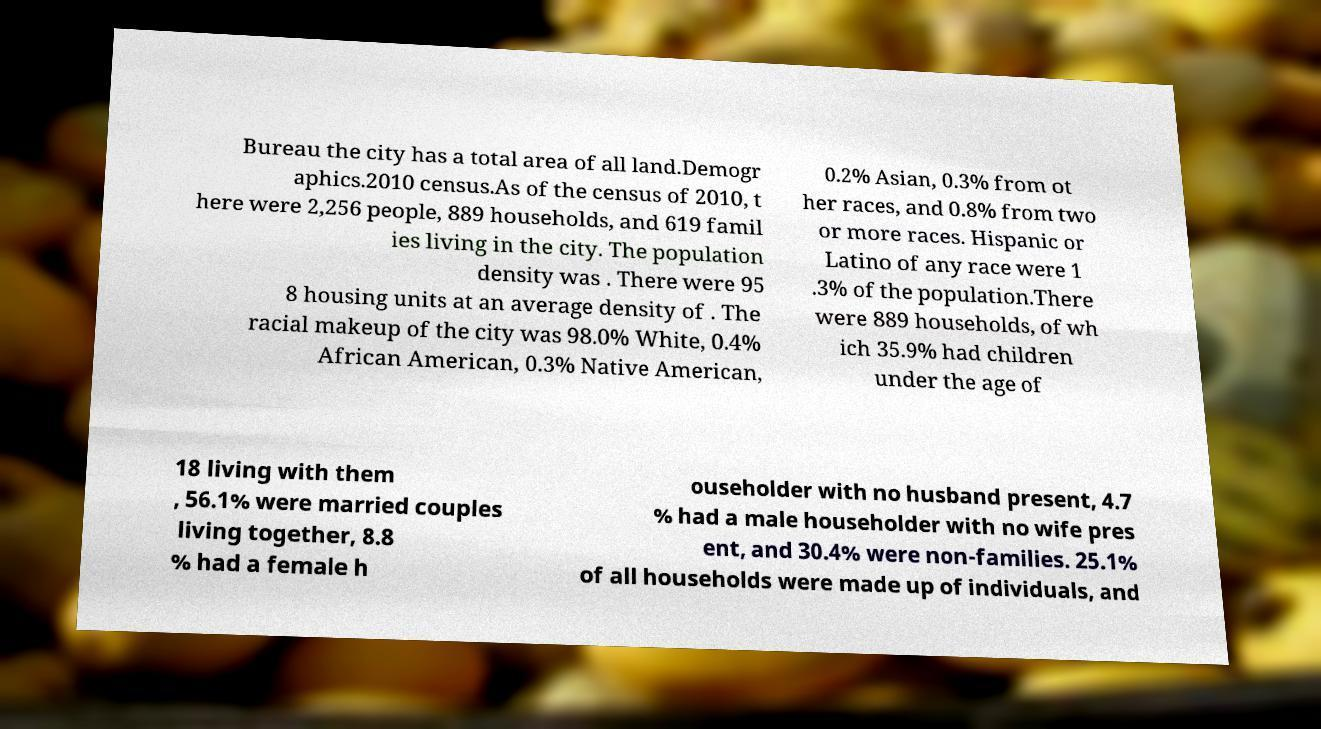Can you accurately transcribe the text from the provided image for me? Bureau the city has a total area of all land.Demogr aphics.2010 census.As of the census of 2010, t here were 2,256 people, 889 households, and 619 famil ies living in the city. The population density was . There were 95 8 housing units at an average density of . The racial makeup of the city was 98.0% White, 0.4% African American, 0.3% Native American, 0.2% Asian, 0.3% from ot her races, and 0.8% from two or more races. Hispanic or Latino of any race were 1 .3% of the population.There were 889 households, of wh ich 35.9% had children under the age of 18 living with them , 56.1% were married couples living together, 8.8 % had a female h ouseholder with no husband present, 4.7 % had a male householder with no wife pres ent, and 30.4% were non-families. 25.1% of all households were made up of individuals, and 